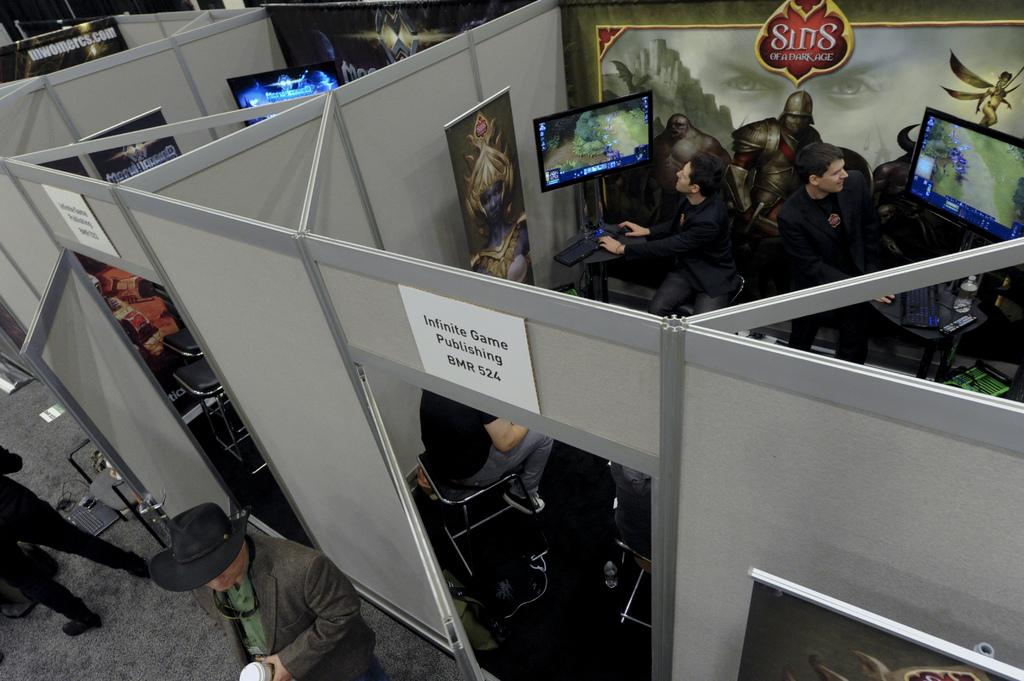<image>
Write a terse but informative summary of the picture. Two men playing computer games next to wallpaper reading Sins of a Dark Age 